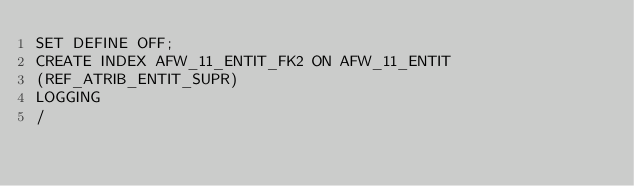Convert code to text. <code><loc_0><loc_0><loc_500><loc_500><_SQL_>SET DEFINE OFF;
CREATE INDEX AFW_11_ENTIT_FK2 ON AFW_11_ENTIT
(REF_ATRIB_ENTIT_SUPR)
LOGGING
/
</code> 